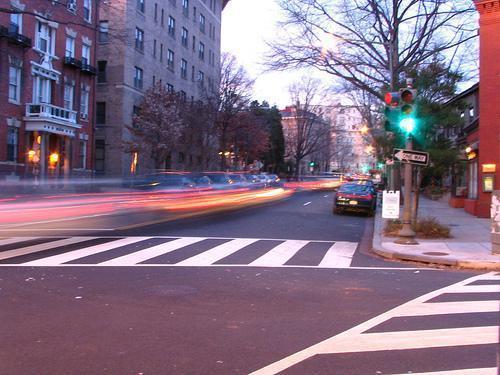How many one way signs are in photo?
Give a very brief answer. 1. 